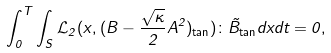<formula> <loc_0><loc_0><loc_500><loc_500>\int _ { 0 } ^ { T } \int _ { S } \mathcal { L } _ { 2 } ( x , ( B - \frac { \sqrt { \kappa } } { 2 } A ^ { 2 } ) _ { \tan } ) \colon \tilde { B } _ { \tan } d x d t = 0 ,</formula> 